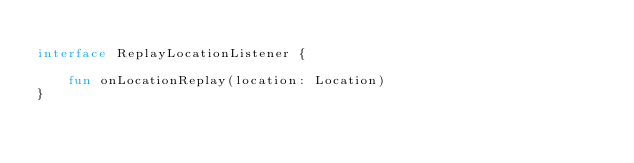<code> <loc_0><loc_0><loc_500><loc_500><_Kotlin_>
interface ReplayLocationListener {

    fun onLocationReplay(location: Location)
}
</code> 